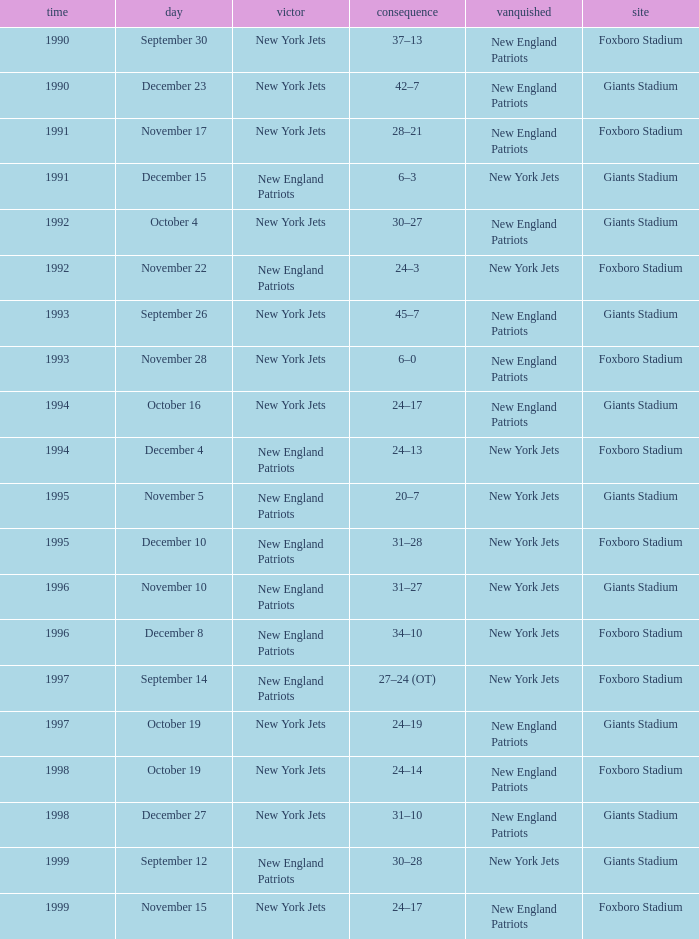What team was the lower when the winner was the new york jets, and a Year earlier than 1994, and a Result of 37–13? New England Patriots. 